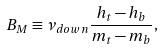Convert formula to latex. <formula><loc_0><loc_0><loc_500><loc_500>B _ { M } \equiv \nu _ { d o w n } \frac { h _ { t } - h _ { b } } { m _ { t } - m _ { b } } ,</formula> 